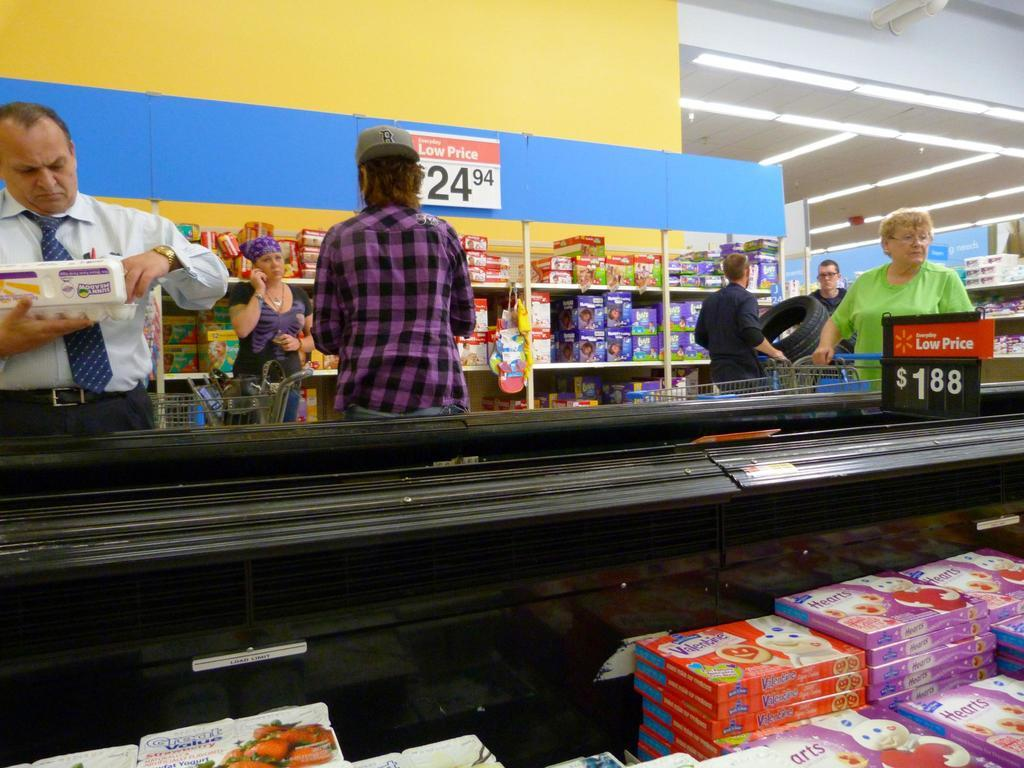<image>
Provide a brief description of the given image. People shopping in a supermarket with some items being a low price of 24.94 